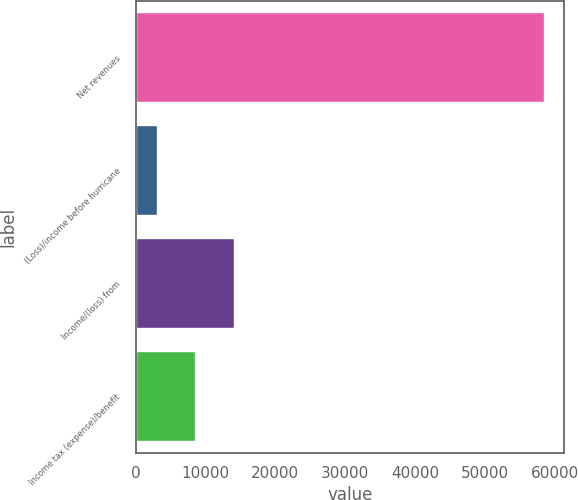Convert chart to OTSL. <chart><loc_0><loc_0><loc_500><loc_500><bar_chart><fcel>Net revenues<fcel>(Loss)/income before hurricane<fcel>Income/(loss) from<fcel>Income tax (expense)/benefit<nl><fcel>58467<fcel>2996<fcel>14090.2<fcel>8543.1<nl></chart> 